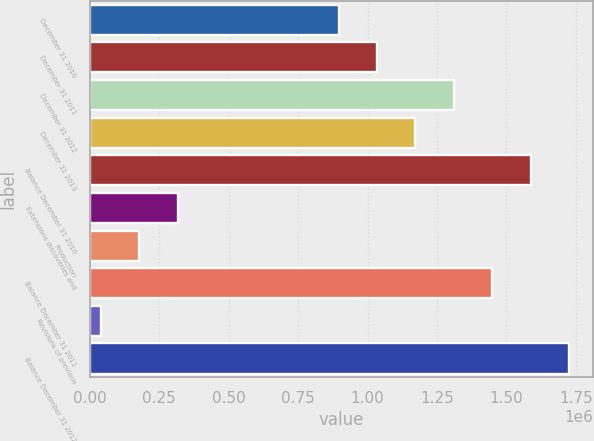Convert chart. <chart><loc_0><loc_0><loc_500><loc_500><bar_chart><fcel>December 31 2010<fcel>December 31 2011<fcel>December 31 2012<fcel>December 31 2013<fcel>Balance December 31 2010<fcel>Extensions discoveries and<fcel>Production<fcel>Balance December 31 2011<fcel>Revisions of previous<fcel>Balance December 31 2012<nl><fcel>895223<fcel>1.03383e+06<fcel>1.31106e+06<fcel>1.17245e+06<fcel>1.58828e+06<fcel>315395<fcel>176784<fcel>1.44967e+06<fcel>38172<fcel>1.72689e+06<nl></chart> 